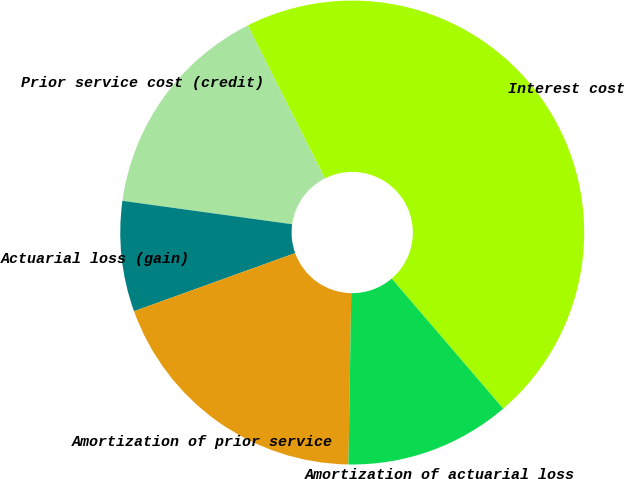<chart> <loc_0><loc_0><loc_500><loc_500><pie_chart><fcel>Interest cost<fcel>Prior service cost (credit)<fcel>Actuarial loss (gain)<fcel>Amortization of prior service<fcel>Amortization of actuarial loss<nl><fcel>46.15%<fcel>15.38%<fcel>7.69%<fcel>19.23%<fcel>11.54%<nl></chart> 